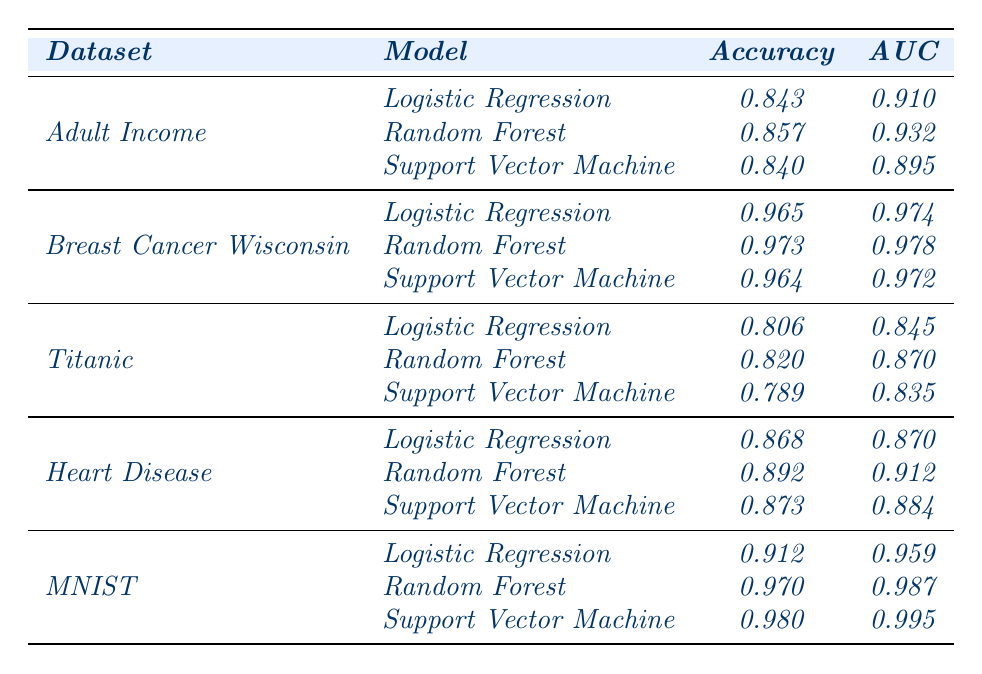What is the accuracy of the Random Forest model on the MNIST dataset? The table lists the accuracy of the Random Forest model for the MNIST dataset as 0.970
Answer: 0.970 Which model has the highest AUC score for the Breast Cancer Wisconsin dataset? The table shows that the Random Forest model has the highest AUC score of 0.978 for the Breast Cancer Wisconsin dataset
Answer: Random Forest What is the difference in accuracy between the Logistic Regression model and Support Vector Machine for the Heart Disease dataset? The accuracy for Logistic Regression is 0.868, and for Support Vector Machine it is 0.873. The difference is 0.873 - 0.868 = 0.005
Answer: 0.005 Which dataset has the lowest accuracy for Logistic Regression? The table indicates that the lowest accuracy for Logistic Regression is for the Titanic dataset at 0.806
Answer: Titanic What is the average AUC score for all models on the Adult Income dataset? The AUC scores for the models on the Adult Income dataset are 0.910, 0.932, and 0.895. The sum is 0.910 + 0.932 + 0.895 = 2.737, and the average is 2.737 / 3 = 0.91233
Answer: Approximately 0.912 Is the accuracy of the Support Vector Machine model on MNIST higher than that of the Random Forest model on the same dataset? According to the table, the accuracy of the Support Vector Machine on MNIST is 0.980, which is higher than the Random Forest model's accuracy of 0.970
Answer: Yes What is the model with the best performance across all datasets based on AUC? By reviewing the AUC scores listed in the table, the Support Vector Machine for the MNIST dataset has the highest AUC of 0.995, indicating it has the best performance
Answer: Support Vector Machine on MNIST How many datasets are evaluated in total for each model type? The table categorizes data across 5 datasets (Adult Income, Breast Cancer Wisconsin, Titanic, Heart Disease, MNIST) and each evaluates 3 model types, leading to a total of 5 datasets
Answer: 5 datasets 